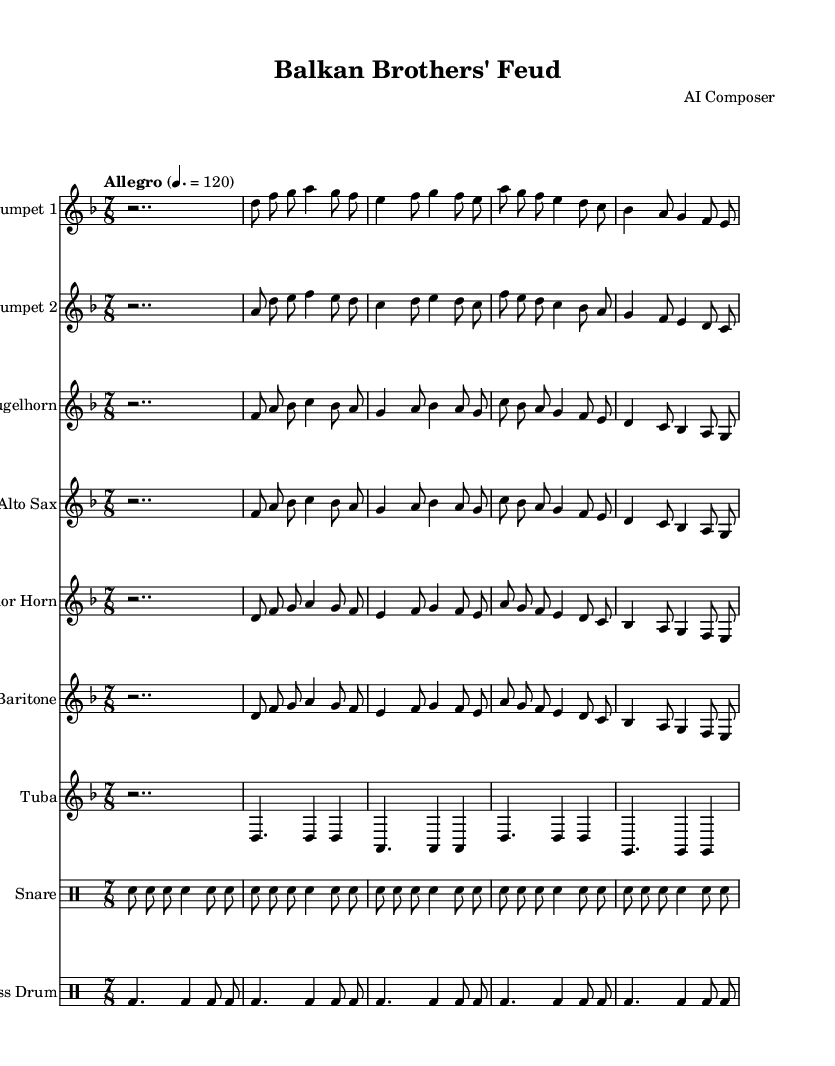What is the key signature of this music? The key signature is D minor, which has one flat (B♭). This is indicated at the beginning of the sheet music with the relevant symbols.
Answer: D minor What is the time signature of the music? The time signature of this piece is 7/8, which means there are seven beats in a measure and the eighth note gets one beat. This is shown at the start of the sheet music.
Answer: 7/8 What is the tempo marking for this piece? The tempo marking indicates the piece should be played at a speed of 120 beats per minute, marked as "Allegro". This is specified above the staff.
Answer: Allegro What are the two main themes of the piece? The two main themes represented in the music are "Brotherhood" and "Conflict". Each theme is designated with comments in the score that label sections of the music for these themes.
Answer: Brotherhood and Conflict How many measures are there in the introduction section? The introduction section consists of 2 measures, represented by the rest symbols and a series of notes that follow the introduction label. We can count these measures based on the notation following the two introductory rests.
Answer: 2 Which instruments are included in this composition? The composition includes a trumpet, flugelhorn, alto sax, tenor horn, baritone horn, tuba, snare drum, and bass drum. Each instrument is labeled at the start of each staff line in the sheet music.
Answer: Trumpet, Flugelhorn, Alto Sax, Tenor Horn, Baritone Horn, Tuba, Snare Drum, Bass Drum What musical form is used to contrast the themes in this piece? The musical form used to contrast the themes is a call-and-response structure, where theme A (Brotherhood) is presented and followed by theme B (Conflict), alternating to express the relationship between the two. This is inferred from the placement of the themes throughout the score.
Answer: Call-and-response 